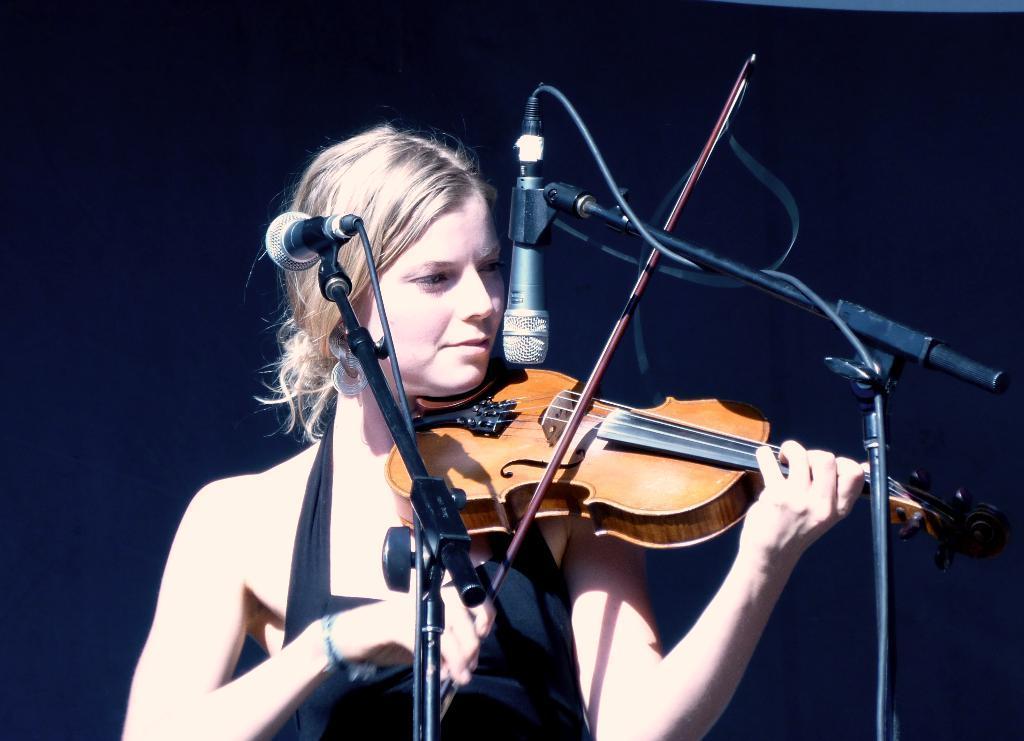Could you give a brief overview of what you see in this image? In this picture we can see a woman, she is playing violin in front of the microphones. 